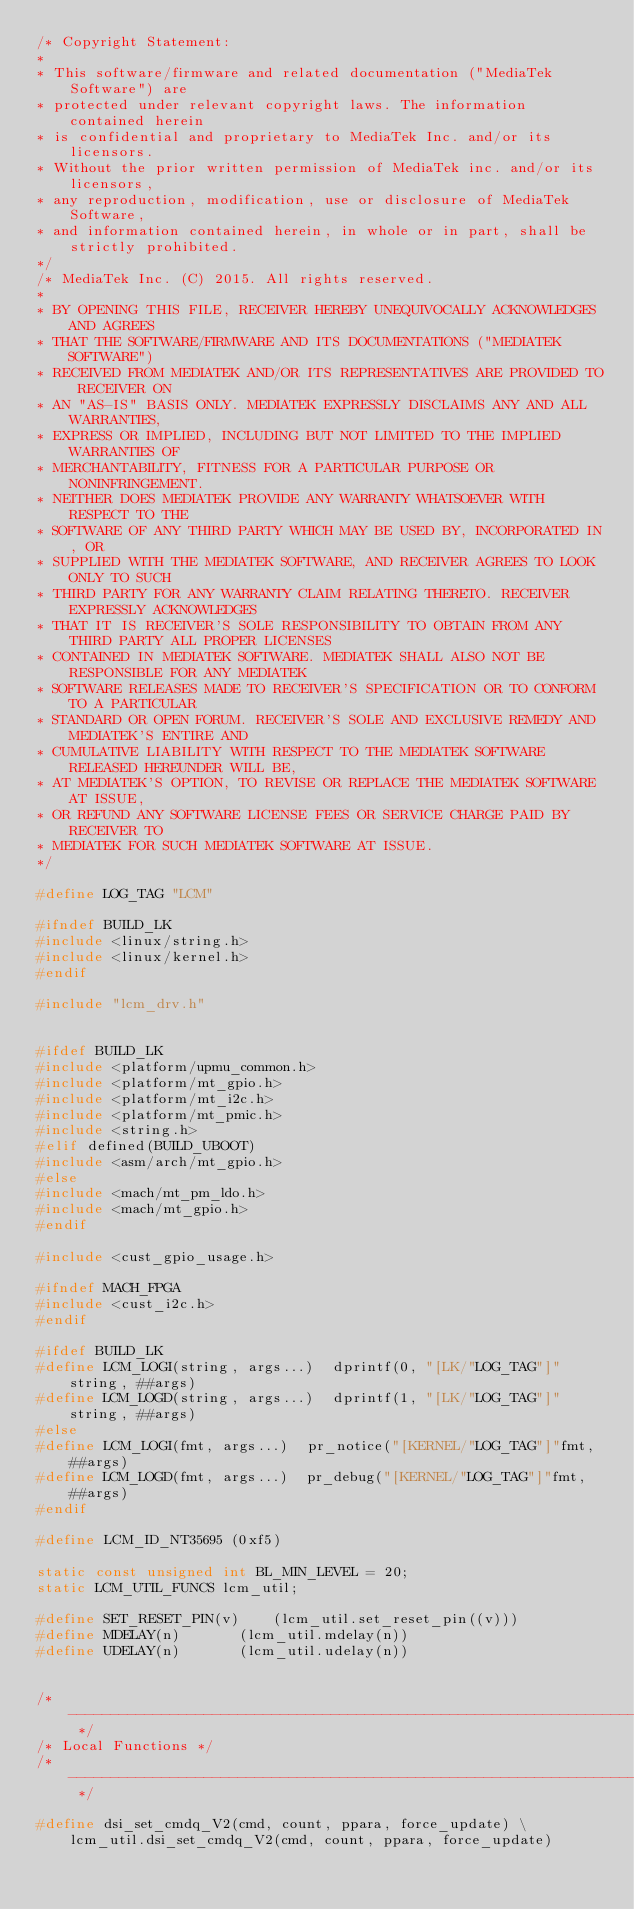<code> <loc_0><loc_0><loc_500><loc_500><_C_>/* Copyright Statement:
*
* This software/firmware and related documentation ("MediaTek Software") are
* protected under relevant copyright laws. The information contained herein
* is confidential and proprietary to MediaTek Inc. and/or its licensors.
* Without the prior written permission of MediaTek inc. and/or its licensors,
* any reproduction, modification, use or disclosure of MediaTek Software,
* and information contained herein, in whole or in part, shall be strictly prohibited.
*/
/* MediaTek Inc. (C) 2015. All rights reserved.
*
* BY OPENING THIS FILE, RECEIVER HEREBY UNEQUIVOCALLY ACKNOWLEDGES AND AGREES
* THAT THE SOFTWARE/FIRMWARE AND ITS DOCUMENTATIONS ("MEDIATEK SOFTWARE")
* RECEIVED FROM MEDIATEK AND/OR ITS REPRESENTATIVES ARE PROVIDED TO RECEIVER ON
* AN "AS-IS" BASIS ONLY. MEDIATEK EXPRESSLY DISCLAIMS ANY AND ALL WARRANTIES,
* EXPRESS OR IMPLIED, INCLUDING BUT NOT LIMITED TO THE IMPLIED WARRANTIES OF
* MERCHANTABILITY, FITNESS FOR A PARTICULAR PURPOSE OR NONINFRINGEMENT.
* NEITHER DOES MEDIATEK PROVIDE ANY WARRANTY WHATSOEVER WITH RESPECT TO THE
* SOFTWARE OF ANY THIRD PARTY WHICH MAY BE USED BY, INCORPORATED IN, OR
* SUPPLIED WITH THE MEDIATEK SOFTWARE, AND RECEIVER AGREES TO LOOK ONLY TO SUCH
* THIRD PARTY FOR ANY WARRANTY CLAIM RELATING THERETO. RECEIVER EXPRESSLY ACKNOWLEDGES
* THAT IT IS RECEIVER'S SOLE RESPONSIBILITY TO OBTAIN FROM ANY THIRD PARTY ALL PROPER LICENSES
* CONTAINED IN MEDIATEK SOFTWARE. MEDIATEK SHALL ALSO NOT BE RESPONSIBLE FOR ANY MEDIATEK
* SOFTWARE RELEASES MADE TO RECEIVER'S SPECIFICATION OR TO CONFORM TO A PARTICULAR
* STANDARD OR OPEN FORUM. RECEIVER'S SOLE AND EXCLUSIVE REMEDY AND MEDIATEK'S ENTIRE AND
* CUMULATIVE LIABILITY WITH RESPECT TO THE MEDIATEK SOFTWARE RELEASED HEREUNDER WILL BE,
* AT MEDIATEK'S OPTION, TO REVISE OR REPLACE THE MEDIATEK SOFTWARE AT ISSUE,
* OR REFUND ANY SOFTWARE LICENSE FEES OR SERVICE CHARGE PAID BY RECEIVER TO
* MEDIATEK FOR SUCH MEDIATEK SOFTWARE AT ISSUE.
*/

#define LOG_TAG "LCM"

#ifndef BUILD_LK
#include <linux/string.h>
#include <linux/kernel.h>
#endif

#include "lcm_drv.h"


#ifdef BUILD_LK
#include <platform/upmu_common.h>
#include <platform/mt_gpio.h>
#include <platform/mt_i2c.h>
#include <platform/mt_pmic.h>
#include <string.h>
#elif defined(BUILD_UBOOT)
#include <asm/arch/mt_gpio.h>
#else
#include <mach/mt_pm_ldo.h>
#include <mach/mt_gpio.h>
#endif

#include <cust_gpio_usage.h>

#ifndef MACH_FPGA
#include <cust_i2c.h>
#endif

#ifdef BUILD_LK
#define LCM_LOGI(string, args...)  dprintf(0, "[LK/"LOG_TAG"]"string, ##args)
#define LCM_LOGD(string, args...)  dprintf(1, "[LK/"LOG_TAG"]"string, ##args)
#else
#define LCM_LOGI(fmt, args...)  pr_notice("[KERNEL/"LOG_TAG"]"fmt, ##args)
#define LCM_LOGD(fmt, args...)  pr_debug("[KERNEL/"LOG_TAG"]"fmt, ##args)
#endif

#define LCM_ID_NT35695 (0xf5)

static const unsigned int BL_MIN_LEVEL = 20;
static LCM_UTIL_FUNCS lcm_util;

#define SET_RESET_PIN(v)    (lcm_util.set_reset_pin((v)))
#define MDELAY(n)       (lcm_util.mdelay(n))
#define UDELAY(n)       (lcm_util.udelay(n))


/* --------------------------------------------------------------------------- */
/* Local Functions */
/* --------------------------------------------------------------------------- */

#define dsi_set_cmdq_V2(cmd, count, ppara, force_update) \
    lcm_util.dsi_set_cmdq_V2(cmd, count, ppara, force_update)</code> 